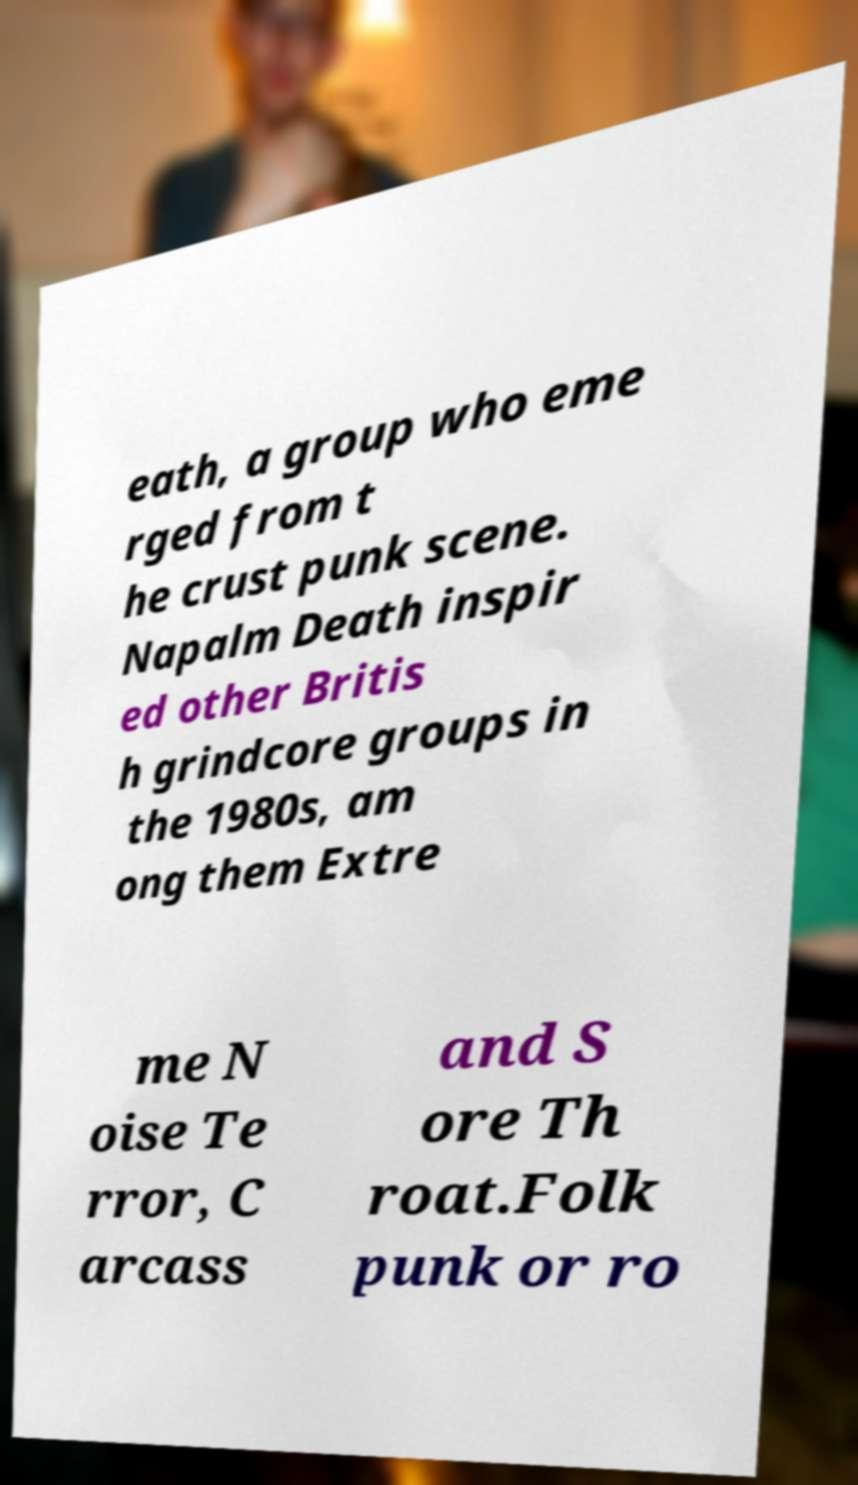For documentation purposes, I need the text within this image transcribed. Could you provide that? eath, a group who eme rged from t he crust punk scene. Napalm Death inspir ed other Britis h grindcore groups in the 1980s, am ong them Extre me N oise Te rror, C arcass and S ore Th roat.Folk punk or ro 